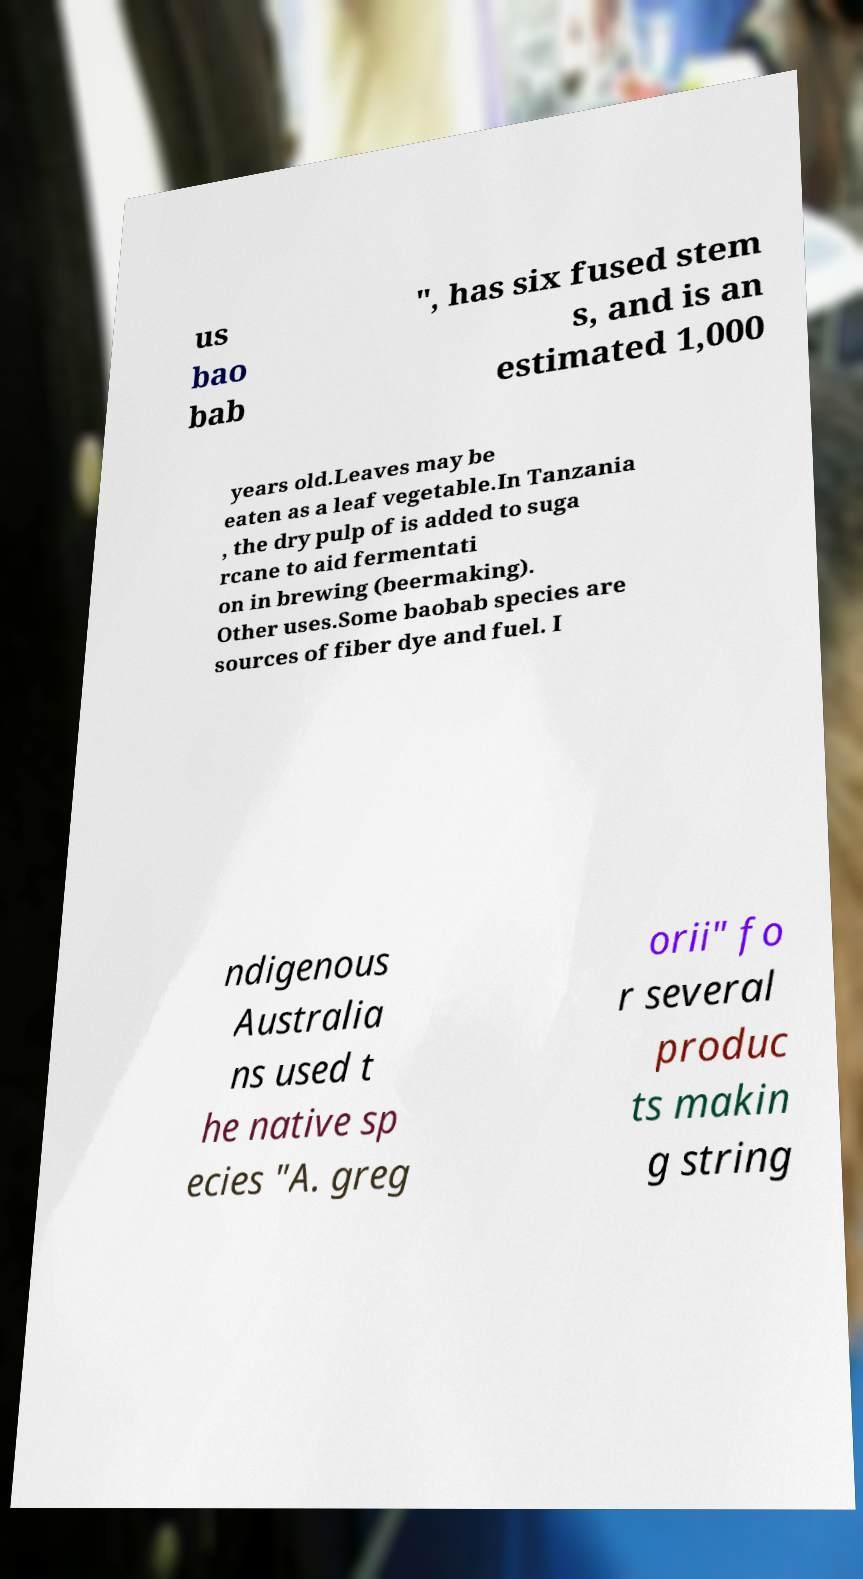For documentation purposes, I need the text within this image transcribed. Could you provide that? us bao bab ", has six fused stem s, and is an estimated 1,000 years old.Leaves may be eaten as a leaf vegetable.In Tanzania , the dry pulp of is added to suga rcane to aid fermentati on in brewing (beermaking). Other uses.Some baobab species are sources of fiber dye and fuel. I ndigenous Australia ns used t he native sp ecies "A. greg orii" fo r several produc ts makin g string 